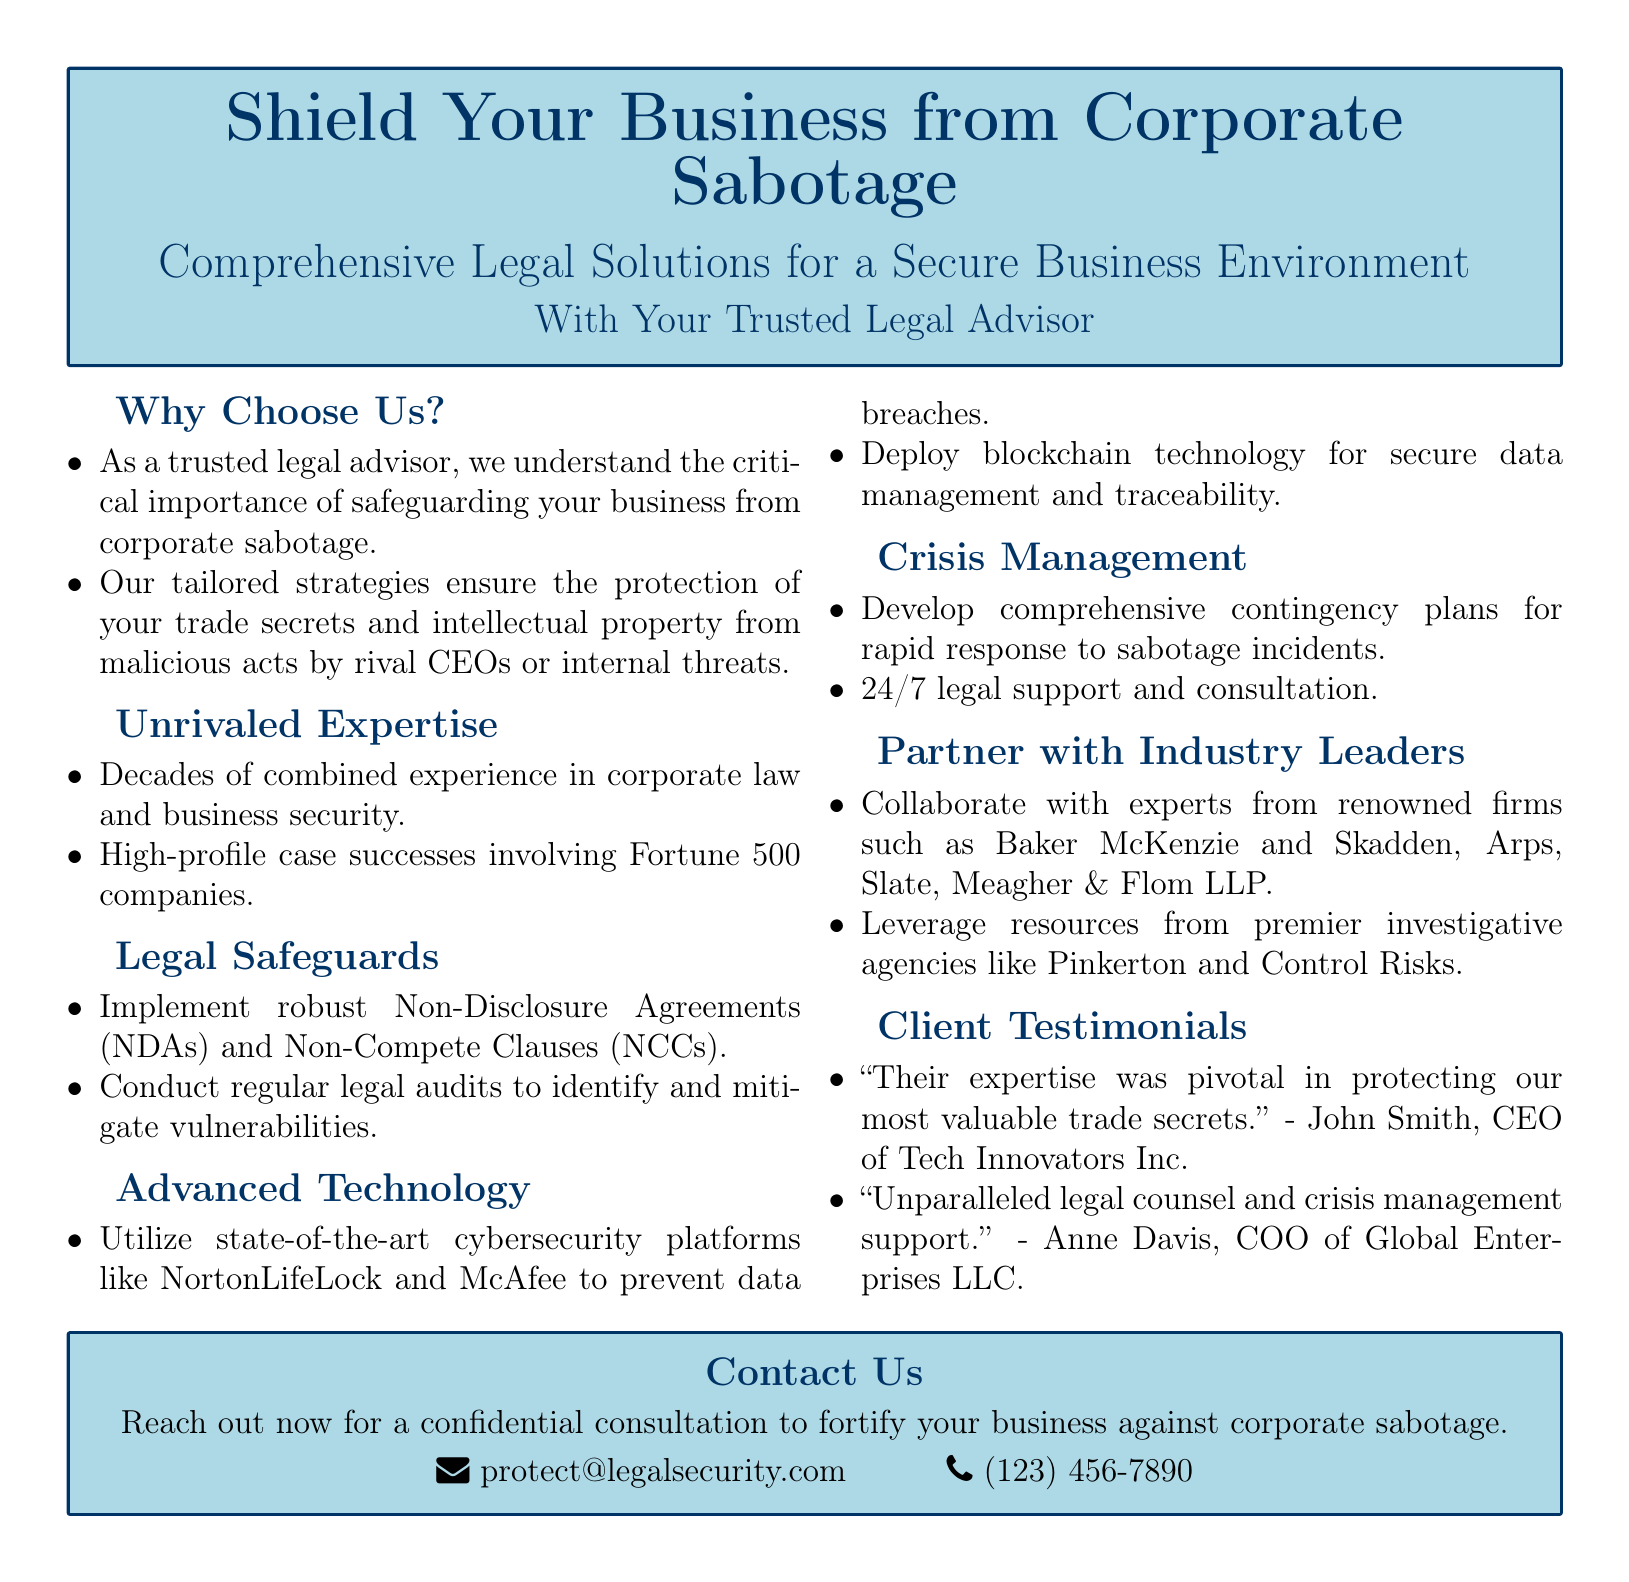What is the main service offered? The advertisement emphasizes the protection of businesses from corporate sabotage through comprehensive legal solutions.
Answer: Comprehensive Legal Solutions Who needs to be safeguarded? The document mentions the importance of safeguarding a business from rival CEOs or internal threats.
Answer: Your business What technology is mentioned for data management? The advertisement refers to using blockchain technology for secure data management and traceability.
Answer: Blockchain technology Which agencies are partnered with for investigative services? The document lists Pinkerton and Control Risks as premier investigative agencies for support.
Answer: Pinkerton and Control Risks What type of agreements does the firm implement for legal safeguards? The document states that robust Non-Disclosure Agreements (NDAs) and Non-Compete Clauses (NCCs) are implemented.
Answer: Non-Disclosure Agreements and Non-Compete Clauses What is the contact email provided? The advertisement includes a specific email address for reaching out for consultations.
Answer: protect@legalsecurity.com How many decades of experience is claimed by the firm? The document mentions decades of combined experience in corporate law and business security.
Answer: Decades What type of support is available 24/7? The advertisement emphasizes the availability of legal support and consultation at all hours.
Answer: Legal support and consultation Who provided a testimonial regarding legal counsel? The document features a testimonial from Anne Davis, the COO of Global Enterprises LLC.
Answer: Anne Davis 